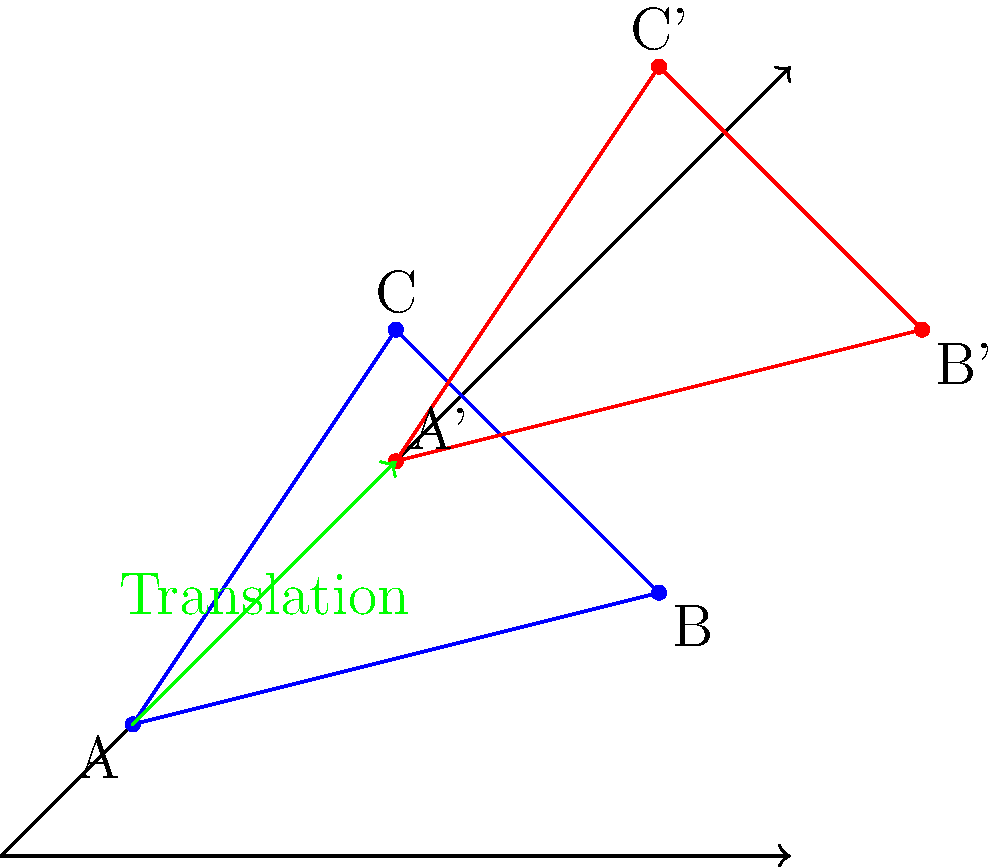In a preserved historical forest in Minnesota, three landmark trees form a triangle. To protect these trees during a restoration project, their positions need to be translated. The original positions of the trees are A(0,0), B(4,1), and C(2,3). After translation, the new position of tree A is A'(2,2). What is the translation vector, and what are the new coordinates of trees B and C? To solve this problem, we'll follow these steps:

1. Determine the translation vector:
   The translation vector is the difference between the new and original positions of tree A.
   Translation vector = A' - A = (2,2) - (0,0) = (2,2)

2. Apply the translation to trees B and C:
   To find the new positions, we add the translation vector to the original coordinates.

   For tree B:
   Original position: B(4,1)
   B' = B + translation vector
   B' = (4,1) + (2,2) = (6,3)

   For tree C:
   Original position: C(2,3)
   C' = C + translation vector
   C' = (2,3) + (2,2) = (4,5)

3. Verify the translation:
   We can check that the distance and orientation between the trees remain the same in both triangles.

Therefore, the translation vector is (2,2), and the new positions of the trees are:
B': (6,3)
C': (4,5)
Answer: Translation vector: (2,2); B': (6,3); C': (4,5) 